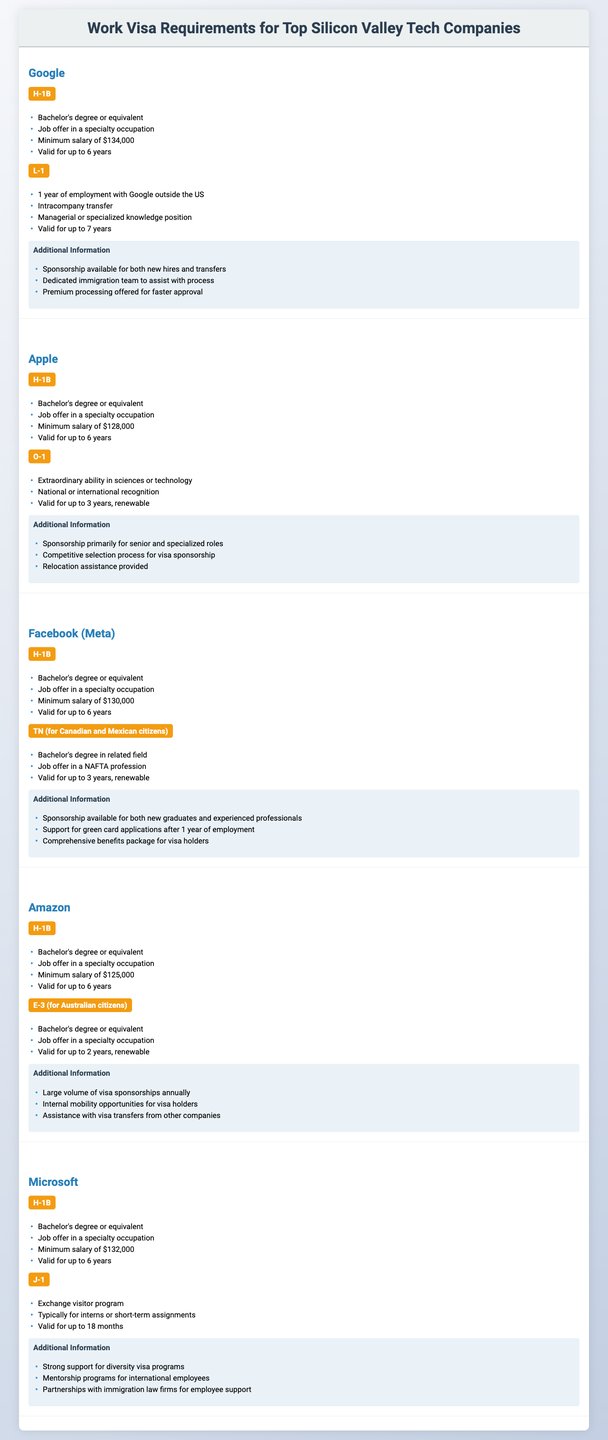What are the minimum salary requirements for H-1B visa holders at Apple? According to the table, the minimum salary requirement for H-1B visa holders at Apple is $128,000.
Answer: $128,000 Which company offers the longest validity period for their L-1 visa? The L-1 visa at Google is valid for up to 7 years, which is longer than other companies listed that offer a maximum of 6 years for their H-1B visas.
Answer: Google Do all companies provide sponsorship for H-1B visas? Yes, all companies listed in the table offer sponsorship for H-1B visas, indicating a consistent practice across these tech companies.
Answer: Yes What is the average minimum salary requirement for H-1B visas across all companies? The minimum salaries for H-1B visas are as follows: Google - $134,000, Apple - $128,000, Facebook - $130,000, Amazon - $125,000, Microsoft - $132,000. Adding these gives 134000 + 128000 + 130000 + 125000 + 132000 = 649000. Dividing by the 5 companies gives 649000 / 5 = 129800.
Answer: $129,800 Which visa type has specific requirements related to "extraordinary ability"? The O-1 visa at Apple requires "extraordinary ability in sciences or technology" and "national or international recognition."
Answer: O-1 Is relocation assistance provided for Amazon visa holders? Yes, the table states that Amazon provides assistance with visa transfers, which indicates support for relocation.
Answer: Yes How many companies offer the J-1 visa type, and which company offers it? Only Microsoft offers the J-1 visa, which is specifically for exchange visitors and typically for interns or short-term assignments.
Answer: 1 company (Microsoft) Which visa type is valid for the shortest duration, and how long is it valid? The E-3 visa for Australian citizens at Amazon is valid for up to 2 years, which is the shortest duration among the visas listed.
Answer: 2 years Do Google and Facebook both support green card applications after a certain period of employment? No, only Facebook mentions support for green card applications after 1 year; Google does not specify this support.
Answer: No What are the requirements for the TN visa, and which company offers it? The TN visa offered by Facebook requires a bachelor's degree in a related field and a job offer in a NAFTA profession, valid for up to 3 years and renewable.
Answer: Facebook 